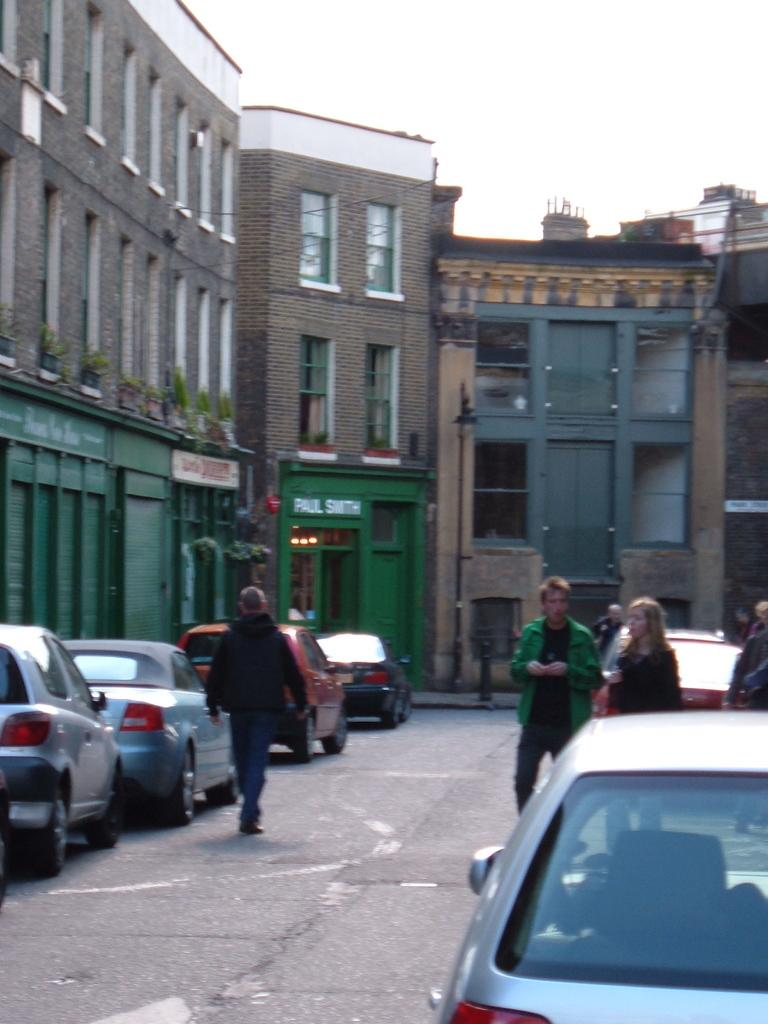What is located in the foreground of the image? There are fleets of cars and a group of people on the road in the foreground of the image. What type of vegetation can be seen in the image? There are house plants visible in the image. What type of structures are present in the image? There are buildings in the image. What is visible at the top of the image? The sky is visible at the top of the image. What can be inferred about the weather from the image? The image appears to have been taken during a sunny day. What type of calculator is being used by the angle in the image? There is no calculator or angle present in the image. How is the string being used by the group of people in the image? There is no string present in the image; the group of people is simply standing on the road. 